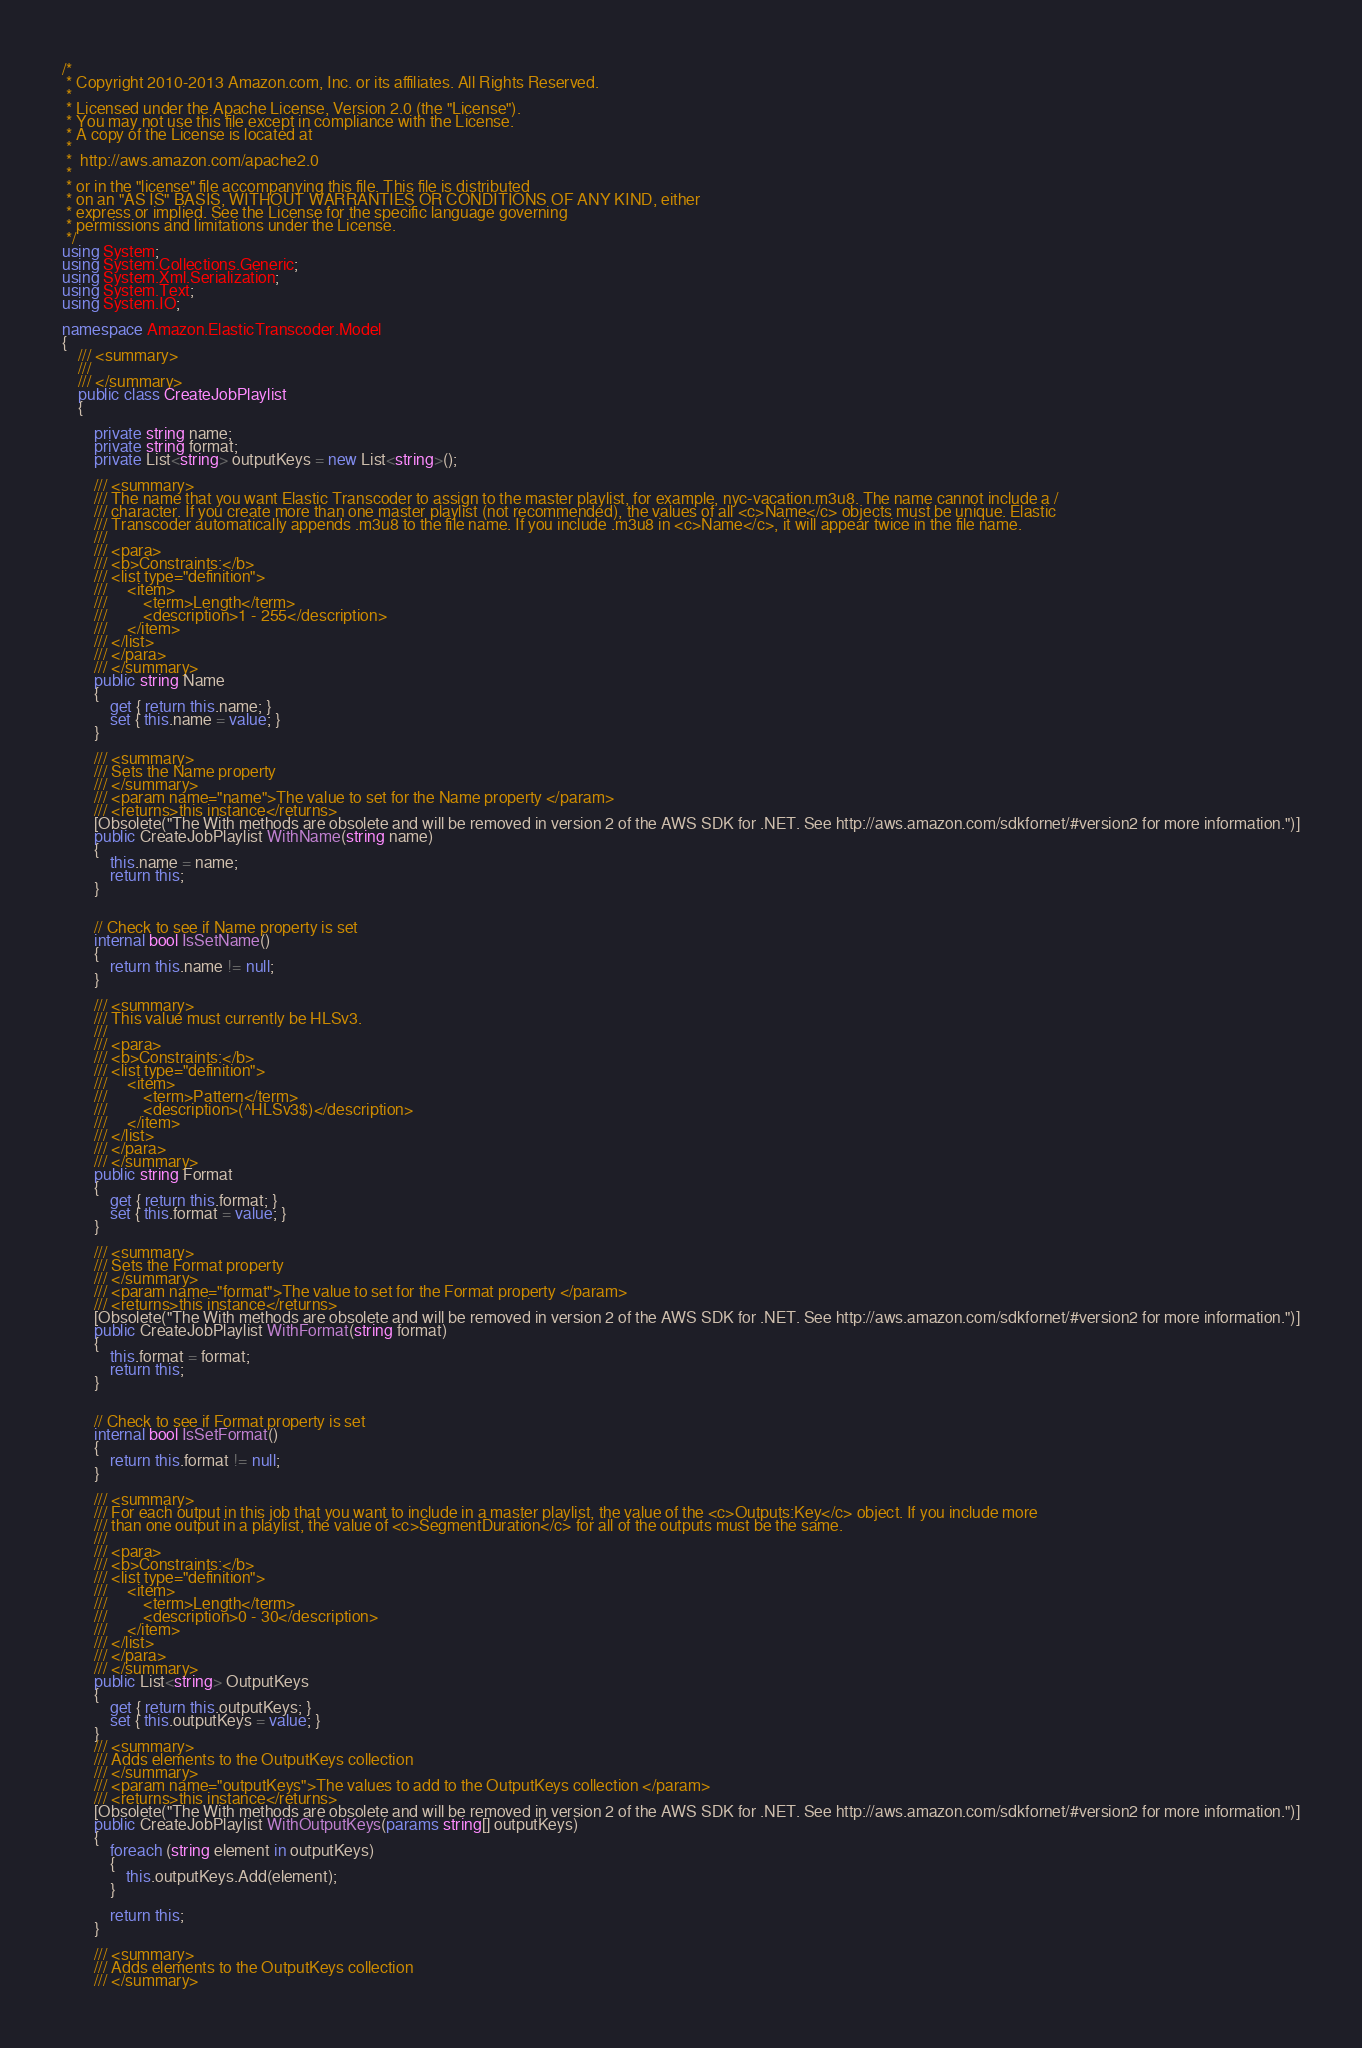Convert code to text. <code><loc_0><loc_0><loc_500><loc_500><_C#_>/*
 * Copyright 2010-2013 Amazon.com, Inc. or its affiliates. All Rights Reserved.
 * 
 * Licensed under the Apache License, Version 2.0 (the "License").
 * You may not use this file except in compliance with the License.
 * A copy of the License is located at
 * 
 *  http://aws.amazon.com/apache2.0
 * 
 * or in the "license" file accompanying this file. This file is distributed
 * on an "AS IS" BASIS, WITHOUT WARRANTIES OR CONDITIONS OF ANY KIND, either
 * express or implied. See the License for the specific language governing
 * permissions and limitations under the License.
 */
using System;
using System.Collections.Generic;
using System.Xml.Serialization;
using System.Text;
using System.IO;

namespace Amazon.ElasticTranscoder.Model
{
    /// <summary>
    /// 
    /// </summary>
    public class CreateJobPlaylist
    {
        
        private string name;
        private string format;
        private List<string> outputKeys = new List<string>();

        /// <summary>
        /// The name that you want Elastic Transcoder to assign to the master playlist, for example, nyc-vacation.m3u8. The name cannot include a /
        /// character. If you create more than one master playlist (not recommended), the values of all <c>Name</c> objects must be unique. Elastic
        /// Transcoder automatically appends .m3u8 to the file name. If you include .m3u8 in <c>Name</c>, it will appear twice in the file name.
        ///  
        /// <para>
        /// <b>Constraints:</b>
        /// <list type="definition">
        ///     <item>
        ///         <term>Length</term>
        ///         <description>1 - 255</description>
        ///     </item>
        /// </list>
        /// </para>
        /// </summary>
        public string Name
        {
            get { return this.name; }
            set { this.name = value; }
        }

        /// <summary>
        /// Sets the Name property
        /// </summary>
        /// <param name="name">The value to set for the Name property </param>
        /// <returns>this instance</returns>
        [Obsolete("The With methods are obsolete and will be removed in version 2 of the AWS SDK for .NET. See http://aws.amazon.com/sdkfornet/#version2 for more information.")]
        public CreateJobPlaylist WithName(string name)
        {
            this.name = name;
            return this;
        }
            

        // Check to see if Name property is set
        internal bool IsSetName()
        {
            return this.name != null;
        }

        /// <summary>
        /// This value must currently be HLSv3.
        ///  
        /// <para>
        /// <b>Constraints:</b>
        /// <list type="definition">
        ///     <item>
        ///         <term>Pattern</term>
        ///         <description>(^HLSv3$)</description>
        ///     </item>
        /// </list>
        /// </para>
        /// </summary>
        public string Format
        {
            get { return this.format; }
            set { this.format = value; }
        }

        /// <summary>
        /// Sets the Format property
        /// </summary>
        /// <param name="format">The value to set for the Format property </param>
        /// <returns>this instance</returns>
        [Obsolete("The With methods are obsolete and will be removed in version 2 of the AWS SDK for .NET. See http://aws.amazon.com/sdkfornet/#version2 for more information.")]
        public CreateJobPlaylist WithFormat(string format)
        {
            this.format = format;
            return this;
        }
            

        // Check to see if Format property is set
        internal bool IsSetFormat()
        {
            return this.format != null;
        }

        /// <summary>
        /// For each output in this job that you want to include in a master playlist, the value of the <c>Outputs:Key</c> object. If you include more
        /// than one output in a playlist, the value of <c>SegmentDuration</c> for all of the outputs must be the same.
        ///  
        /// <para>
        /// <b>Constraints:</b>
        /// <list type="definition">
        ///     <item>
        ///         <term>Length</term>
        ///         <description>0 - 30</description>
        ///     </item>
        /// </list>
        /// </para>
        /// </summary>
        public List<string> OutputKeys
        {
            get { return this.outputKeys; }
            set { this.outputKeys = value; }
        }
        /// <summary>
        /// Adds elements to the OutputKeys collection
        /// </summary>
        /// <param name="outputKeys">The values to add to the OutputKeys collection </param>
        /// <returns>this instance</returns>
        [Obsolete("The With methods are obsolete and will be removed in version 2 of the AWS SDK for .NET. See http://aws.amazon.com/sdkfornet/#version2 for more information.")]
        public CreateJobPlaylist WithOutputKeys(params string[] outputKeys)
        {
            foreach (string element in outputKeys)
            {
                this.outputKeys.Add(element);
            }

            return this;
        }

        /// <summary>
        /// Adds elements to the OutputKeys collection
        /// </summary></code> 